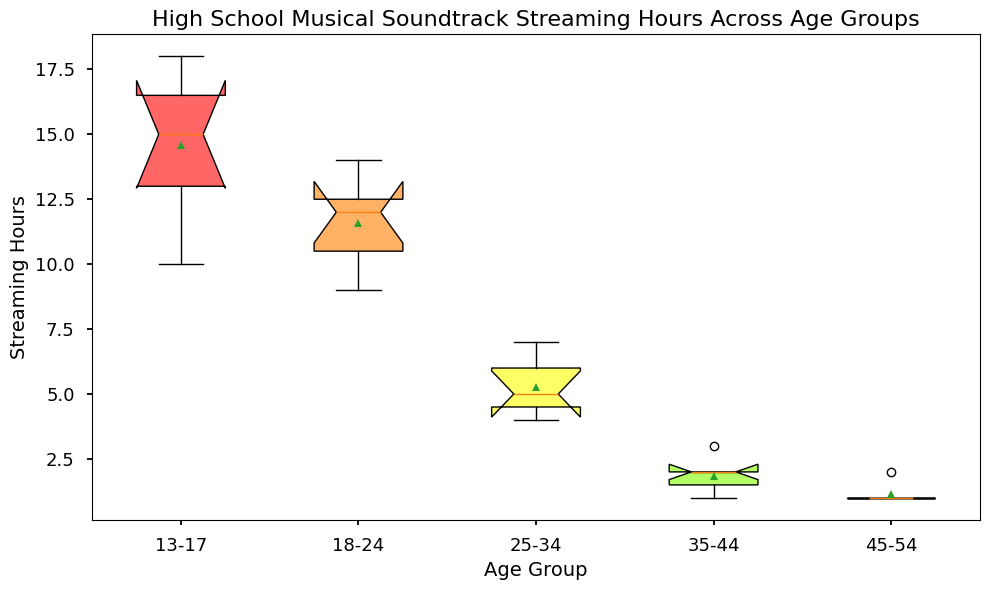Which age group has the highest median streaming hours? Looking at the box plot, the median is represented by the line inside each box. The highest median is seen in the 13-17 age group.
Answer: 13-17 Which age group has the smallest interquartile range (IQR) of streaming hours? The IQR is depicted by the width of the box. The 45-54 age group has the smallest box, indicating the smallest IQR.
Answer: 45-54 What is the mean streaming hours for the 18-24 age group? The mean is represented by a dot inside each box. For the 18-24 age group, locate the dot inside the box.
Answer: 11.571 (approx.) Compare the range of streaming hours between the 25-34 and 35-44 age groups. Which one is larger? The range is indicated by the length between the whiskers (smallest and largest values). The range for the 25-34 age group is from 4 to 7 (3 hours), and the 35-44 age group is from 1 to 3 (2 hours).
Answer: 25-34 Which age group has the highest variability in streaming hours? Variability can be inferred from the length of the whiskers and the spread of the boxes. The 13-17 age group shows the largest variability with the widest whiskers and spread out box.
Answer: 13-17 Are there any age groups with potential outliers? If so, which ones? Outliers would be shown as individual dots outside the whiskers. There are no such dots in any age group, indicating no potential outliers.
Answer: None What can you say about the central tendency in the 45-54 age group? The central tendency is represented by the median and provided by the mean dot in the figure. The median and mean of the 45-54 age group are very close, concentrated around 1 hour.
Answer: Low central tendency Which age group shows the least interest in streaming the High School Musical Soundtrack? By observing the medians and the overall spread of the data, the 45-54 age group has the lowest streaming hours with both the median and most data points around 1 hour.
Answer: 45-54 How does the median streaming hours for the 18-24 age group compare to that of the 25-34 age group? Compare the line inside the boxes for 18-24 and 25-34 age groups; the median for 18-24 is higher than that of the 25-34 age group.
Answer: Higher 